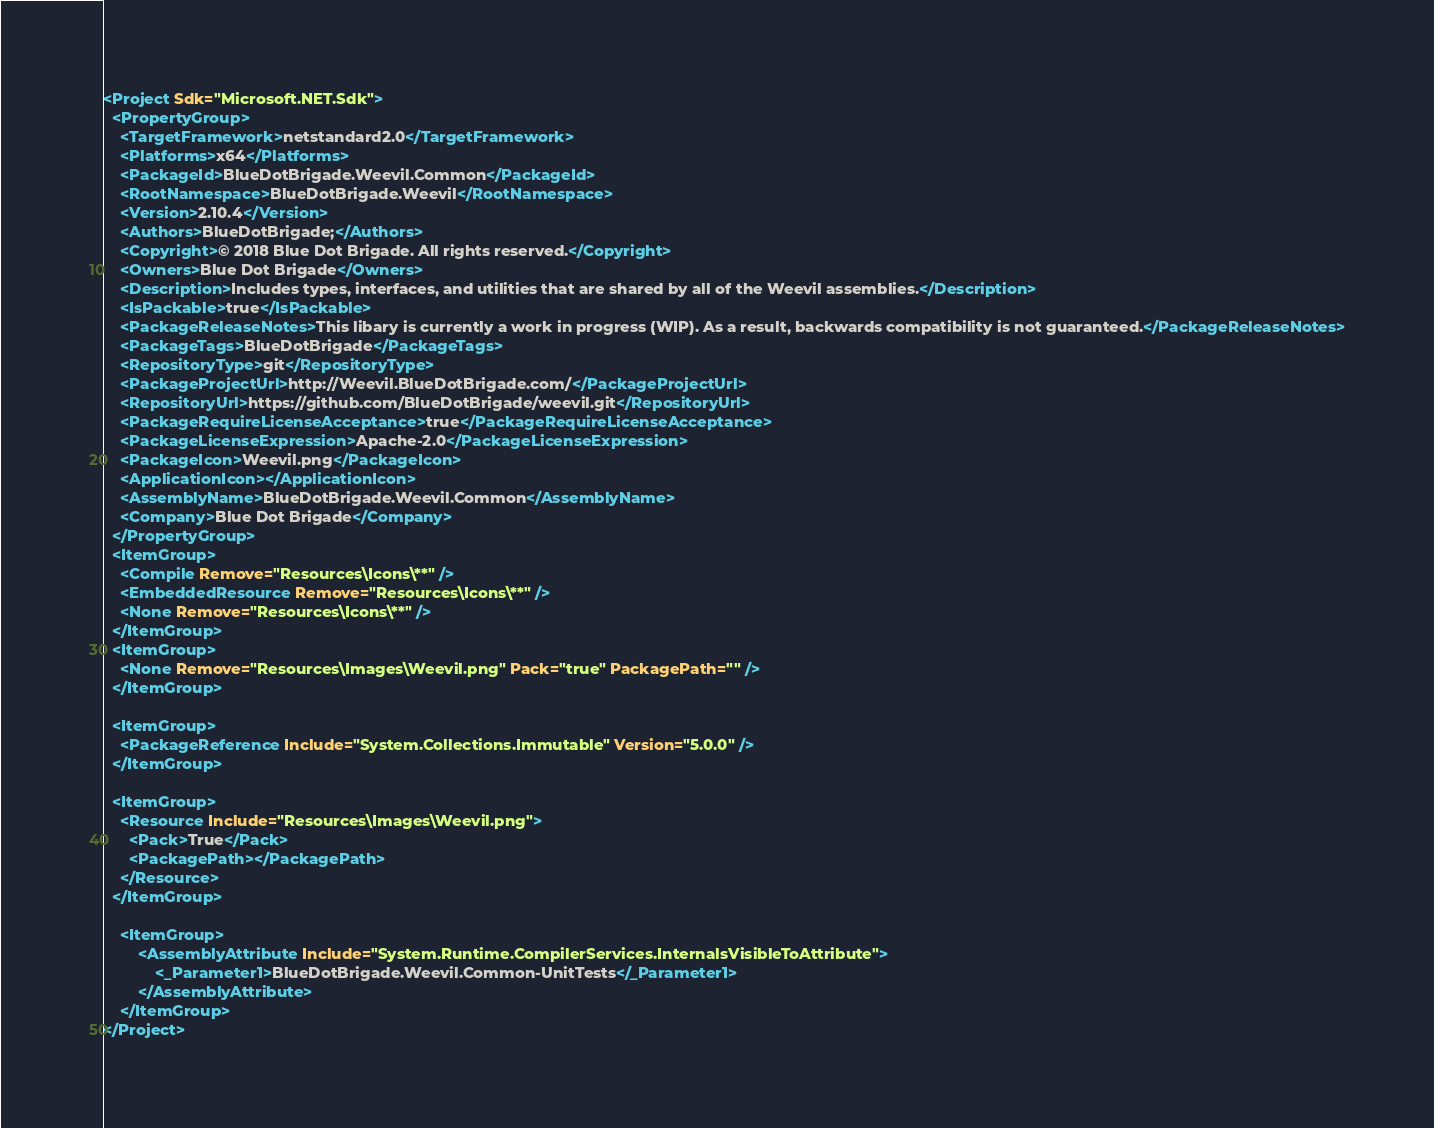Convert code to text. <code><loc_0><loc_0><loc_500><loc_500><_XML_><Project Sdk="Microsoft.NET.Sdk">
  <PropertyGroup>
    <TargetFramework>netstandard2.0</TargetFramework>
	<Platforms>x64</Platforms>
	<PackageId>BlueDotBrigade.Weevil.Common</PackageId>
    <RootNamespace>BlueDotBrigade.Weevil</RootNamespace>
    <Version>2.10.4</Version>
    <Authors>BlueDotBrigade;</Authors>
	<Copyright>© 2018 Blue Dot Brigade. All rights reserved.</Copyright>
	<Owners>Blue Dot Brigade</Owners>
    <Description>Includes types, interfaces, and utilities that are shared by all of the Weevil assemblies.</Description>
    <IsPackable>true</IsPackable>
	<PackageReleaseNotes>This libary is currently a work in progress (WIP). As a result, backwards compatibility is not guaranteed.</PackageReleaseNotes>
	<PackageTags>BlueDotBrigade</PackageTags>
	<RepositoryType>git</RepositoryType>
	<PackageProjectUrl>http://Weevil.BlueDotBrigade.com/</PackageProjectUrl>
	<RepositoryUrl>https://github.com/BlueDotBrigade/weevil.git</RepositoryUrl>
	<PackageRequireLicenseAcceptance>true</PackageRequireLicenseAcceptance>
	<PackageLicenseExpression>Apache-2.0</PackageLicenseExpression>
	<PackageIcon>Weevil.png</PackageIcon>
	<ApplicationIcon></ApplicationIcon>
	<AssemblyName>BlueDotBrigade.Weevil.Common</AssemblyName>
	<Company>Blue Dot Brigade</Company>
  </PropertyGroup>
  <ItemGroup>
    <Compile Remove="Resources\Icons\**" />
    <EmbeddedResource Remove="Resources\Icons\**" />
    <None Remove="Resources\Icons\**" />
  </ItemGroup>
  <ItemGroup>
    <None Remove="Resources\Images\Weevil.png" Pack="true" PackagePath="" />
  </ItemGroup>

  <ItemGroup>
    <PackageReference Include="System.Collections.Immutable" Version="5.0.0" />
  </ItemGroup>

  <ItemGroup>
    <Resource Include="Resources\Images\Weevil.png">
      <Pack>True</Pack>
      <PackagePath></PackagePath>
    </Resource>
  </ItemGroup>
  
  	<ItemGroup>
		<AssemblyAttribute Include="System.Runtime.CompilerServices.InternalsVisibleToAttribute">
			<_Parameter1>BlueDotBrigade.Weevil.Common-UnitTests</_Parameter1>
		</AssemblyAttribute>
	</ItemGroup>
</Project>
</code> 